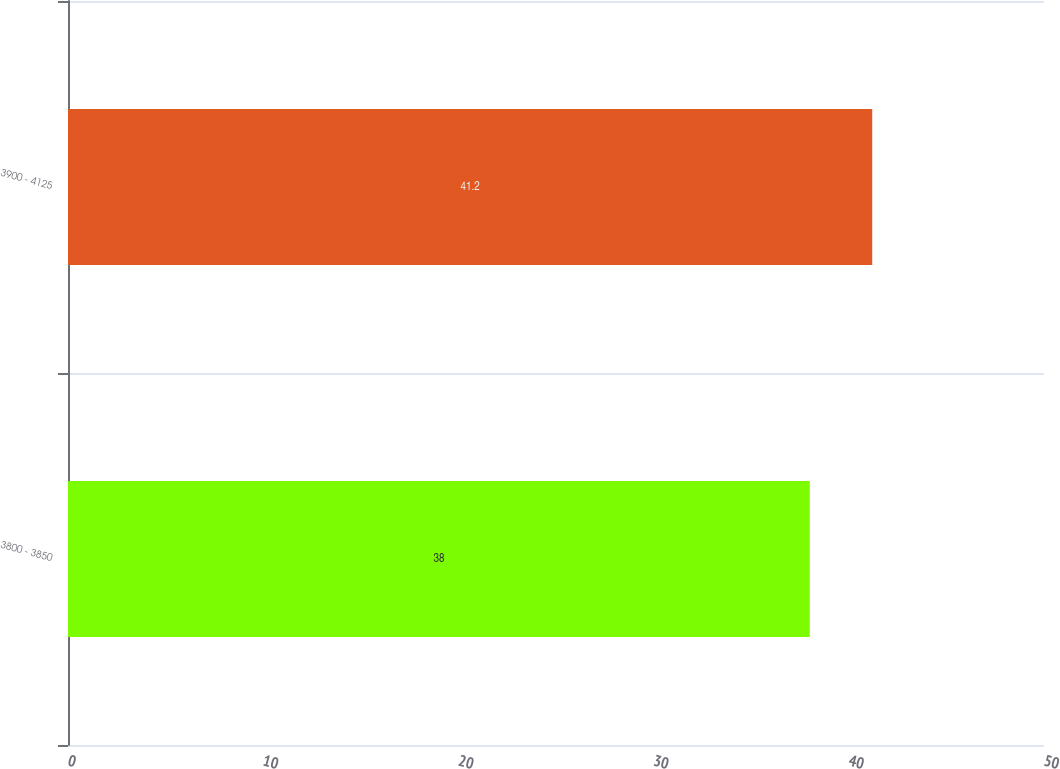Convert chart to OTSL. <chart><loc_0><loc_0><loc_500><loc_500><bar_chart><fcel>3800 - 3850<fcel>3900 - 4125<nl><fcel>38<fcel>41.2<nl></chart> 